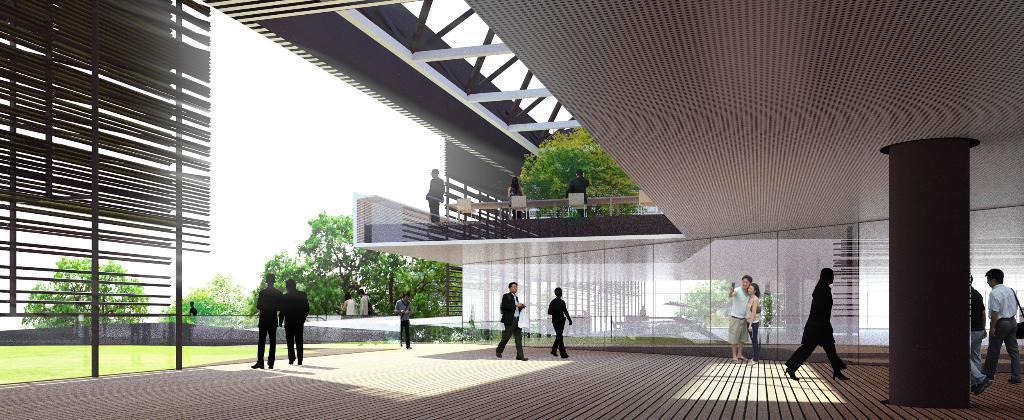Please provide a concise description of this image. This looks like an edited image. There are few people walking and few people standing. This is a building. I can see a pillar. I think these are the glass doors. I can see the trees. This is the grass. 